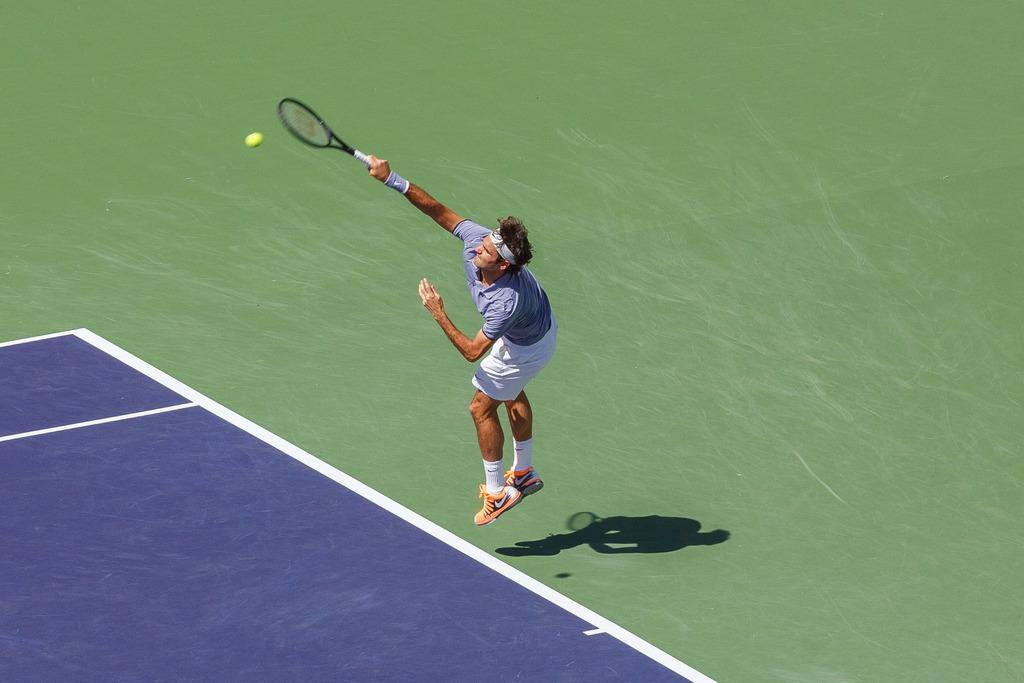What is the main subject of the image? The main subject of the image is a player. What is the player wearing? The player is wearing a jersey. What object is the player holding in his right hand? The player is holding a bat in his right hand. How many rabbits can be seen playing with the player in the image? There are no rabbits present in the image. What type of weather is depicted in the image during the rainstorm? There is no rainstorm depicted in the image; it is a clear scene with the player and his bat. 